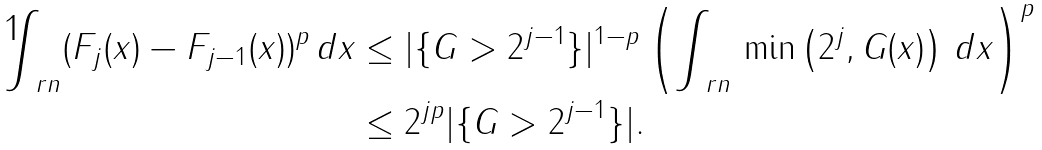Convert formula to latex. <formula><loc_0><loc_0><loc_500><loc_500>\int _ { \ r n } ( F _ { j } ( x ) - F _ { j - 1 } ( x ) ) ^ { p } \, d x & \leq | \{ G > 2 ^ { j - 1 } \} | ^ { 1 - p } \left ( \int _ { \ r n } \, \min \left ( 2 ^ { j } , G ( x ) \right ) \, d x \right ) ^ { p } \\ & \leq 2 ^ { j p } | \{ G > 2 ^ { j - 1 } \} | .</formula> 